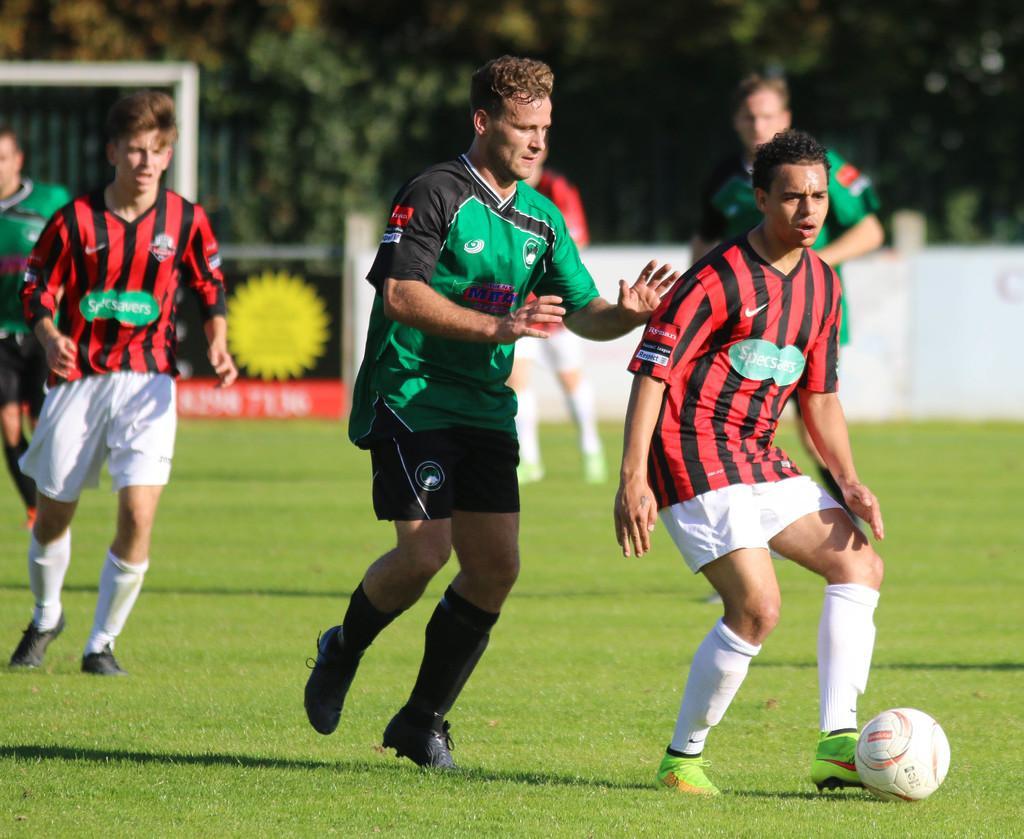Can you describe this image briefly? In the image we can see few persons were standing. Three of them were in red color t shirt and remaining were in green color t shirt. On the right we can see one ball. In the background there is a tree,banner and grass. 